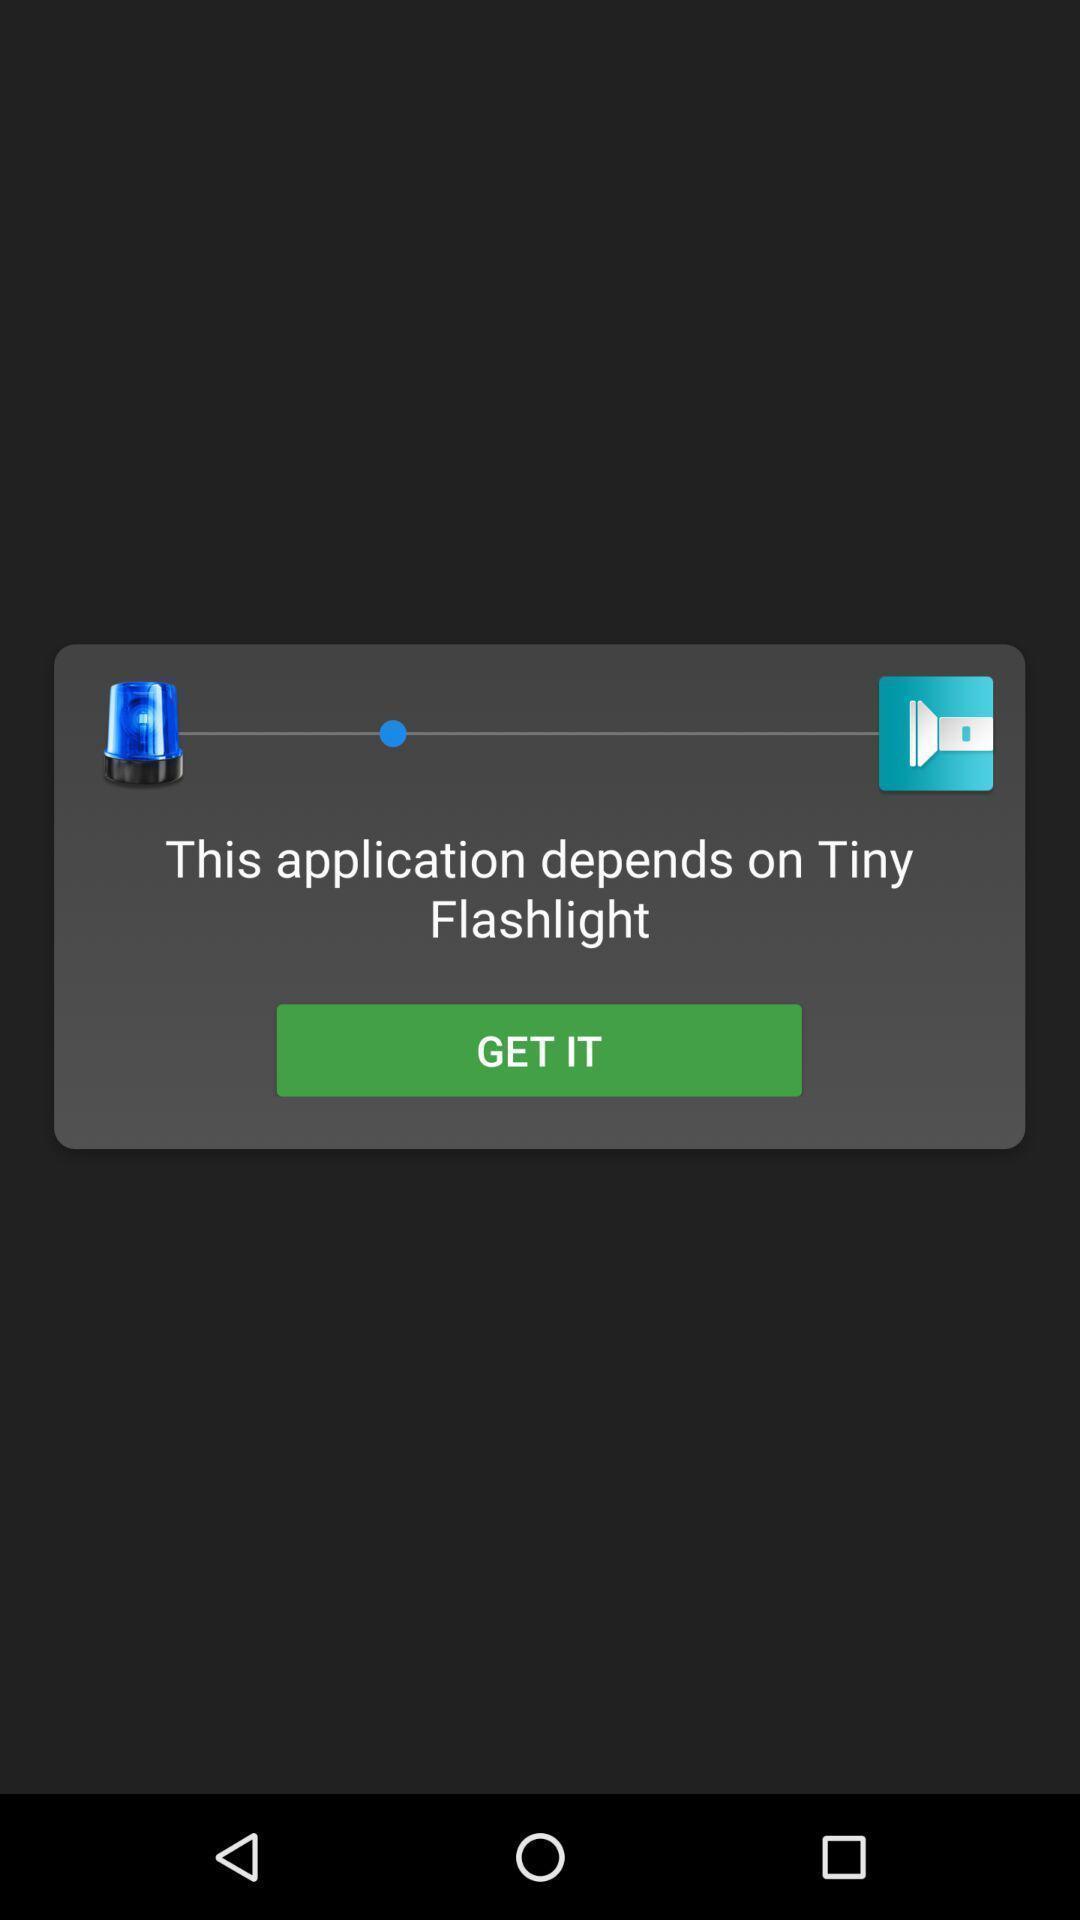Describe the key features of this screenshot. Pop-up showing flashlight settings. 